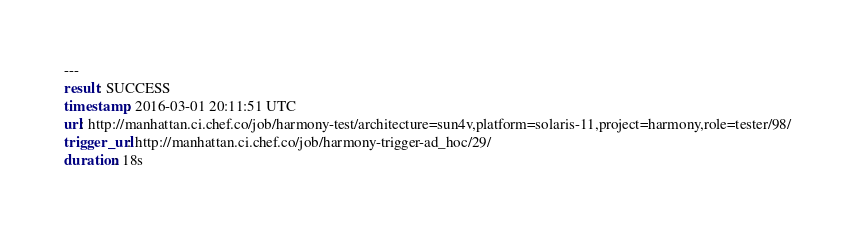Convert code to text. <code><loc_0><loc_0><loc_500><loc_500><_YAML_>---
result: SUCCESS
timestamp: 2016-03-01 20:11:51 UTC
url: http://manhattan.ci.chef.co/job/harmony-test/architecture=sun4v,platform=solaris-11,project=harmony,role=tester/98/
trigger_url: http://manhattan.ci.chef.co/job/harmony-trigger-ad_hoc/29/
duration: 18s
</code> 